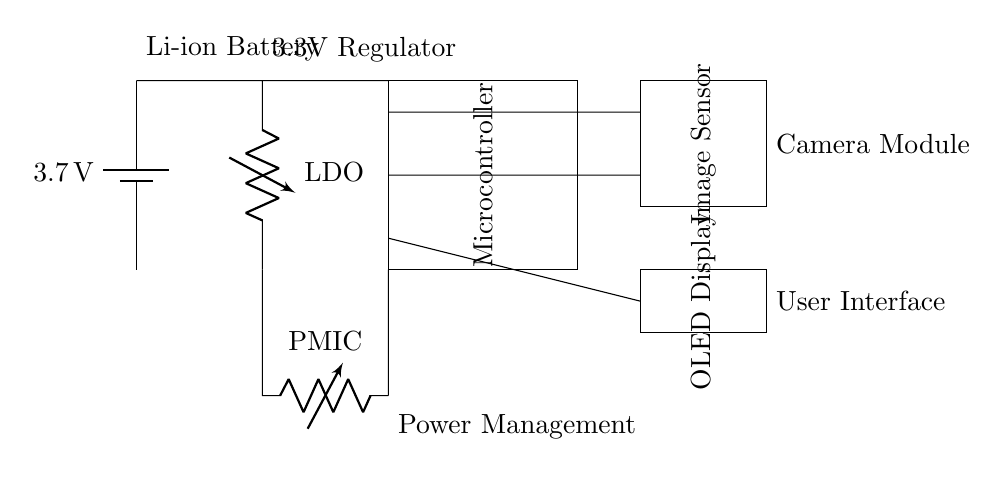What is the power supply voltage? The power supply in the circuit is a battery labeled with a voltage of 3.7 volts, indicating the potential difference provided by the battery.
Answer: 3.7 volts What is the main function of the microcontroller? The microcontroller is a key component in this circuit that processes data from the image sensor and likely controls the OLED display, making it vital for the functionality of the handheld plant identification device.
Answer: Control and processing What is the purpose of the LDO in this circuit? The LDO, or Low Dropout Regulator, is used to regulate the voltage from the power supply down to a stable 3.3 volts necessary for the operation of the microcontroller and other components in this low-energy consumption circuit.
Answer: Voltage regulation Which component interfaces with the external environment to capture images? The image sensor is the component responsible for capturing images of plants, allowing for image recognition which is crucial for identification purposes in this handheld device.
Answer: Image Sensor Explain how the components are powered in this circuit. The components are powered by the battery that supplies 3.7 volts, which first passes through the LDO to stabilize it to 3.3 volts for the microcontroller and other devices. Additionally, a power management IC ensures efficient distribution of power to the components based on their requirements.
Answer: Battery, LDO, PMIC What type of display is used in the circuit? The circuit uses an OLED display, which is indicated in the diagram as the user interface for visual output, making it suitable for low power applications due to its energy-efficient properties.
Answer: OLED Display 